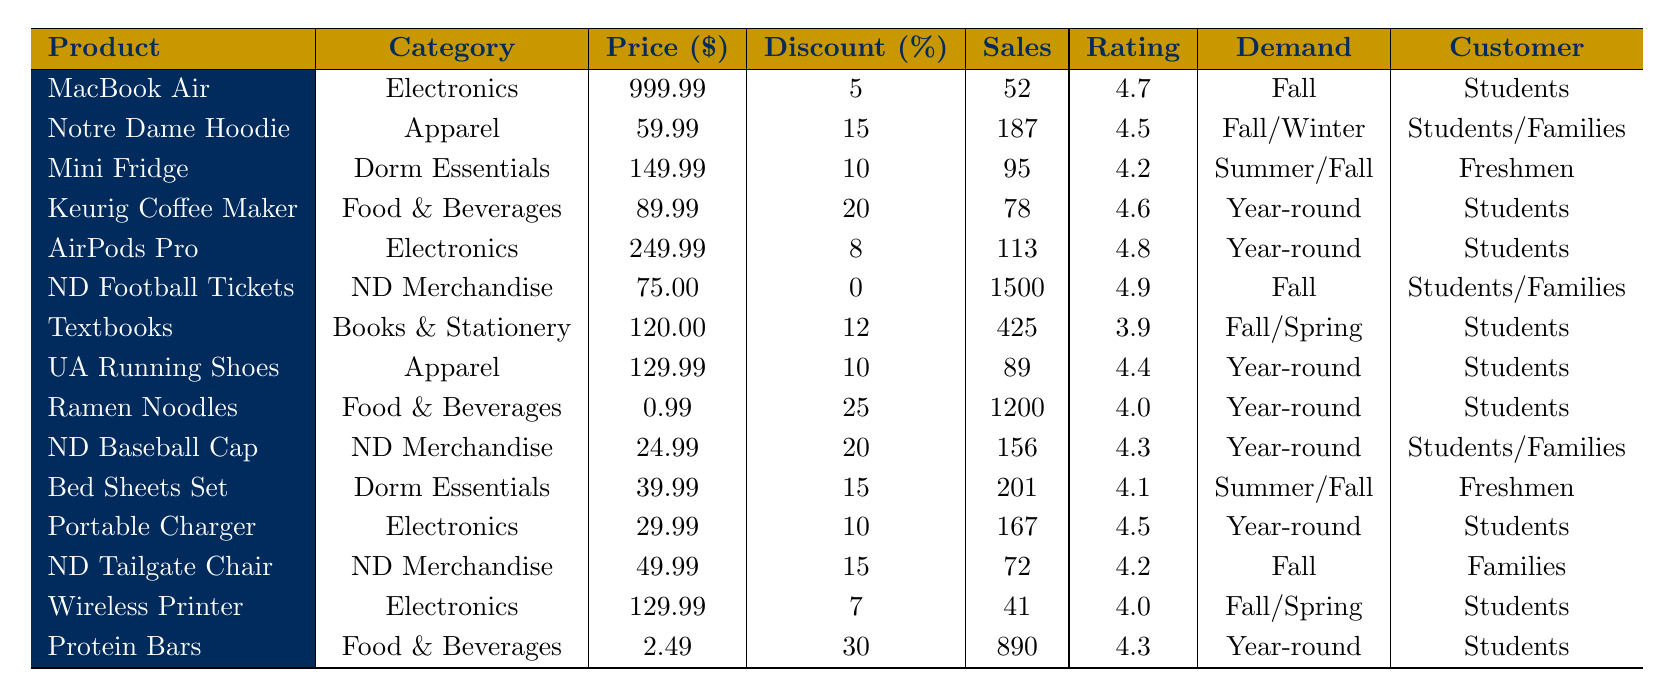What is the top-selling product among Notre Dame students and their families? The product with the highest sales volume is the Notre Dame Football Tickets, which sold 1500 units last month
Answer: Notre Dame Football Tickets Which product category has the highest average price? By comparing the average prices of each category, Electronics averages $426.65, Apparel $61.99, Dorm Essentials $84.99, Food & Beverages $30.99, Books & Stationery $120, and Notre Dame Merchandise $73.33. The highest is Electronics
Answer: Electronics What is the discount percentage for Ramen Noodles? The discount percentage for Ramen Noodles, which is listed in the table, is 25%
Answer: 25% How many items sold last month belong to the Food & Beverages category? The total sales volume of Food & Beverages products (Keurig Coffee Maker, Ramen Noodles, and Protein Bars) is 78 + 1200 + 890 = 2168
Answer: 2168 Which product has the lowest customer rating? By examining the customer ratings in the table, Textbooks has the lowest rating at 3.9
Answer: 3.9 Is the average price of Notre Dame merchandise higher than that of Dorm Essentials? The average price for Notre Dame Merchandise is $73.33, and for Dorm Essentials, it is $84.99. Therefore, Notre Dame Merchandise is lower than Dorm Essentials
Answer: No How much more do AirPods Pro cost than a Notre Dame Baseball Cap after applying discounts? AirPods Pro costs $249.99 and the Baseball Cap costs $24.99 before discounts. After applying their respective discounts (8% and 20%), AirPods Pro costs $229.99 and the cap is $19.99. The difference is $229.99 - $19.99 = $210
Answer: $210 Which product has the highest discount percentage and what is that percentage? Checking the table, Protein Bars have the highest discount percentage of 30%
Answer: 30% How many products sold more than 200 units last month? The products with sales over 200 units are Notre Dame Football Tickets (1500), Ramen Noodles (1200), Textbooks (425), and Bed Sheets Set (201), totaling 4 products
Answer: 4 What is the average price of Apparel products from the table? The average price of Apparel products (Notre Dame Hoodie and UA Running Shoes) is calculated as (59.99 + 129.99) / 2 = 94.99
Answer: 94.99 